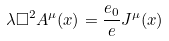Convert formula to latex. <formula><loc_0><loc_0><loc_500><loc_500>\lambda \Box ^ { 2 } A ^ { \mu } ( x ) = \frac { e _ { 0 } } { e } J ^ { \mu } ( x )</formula> 